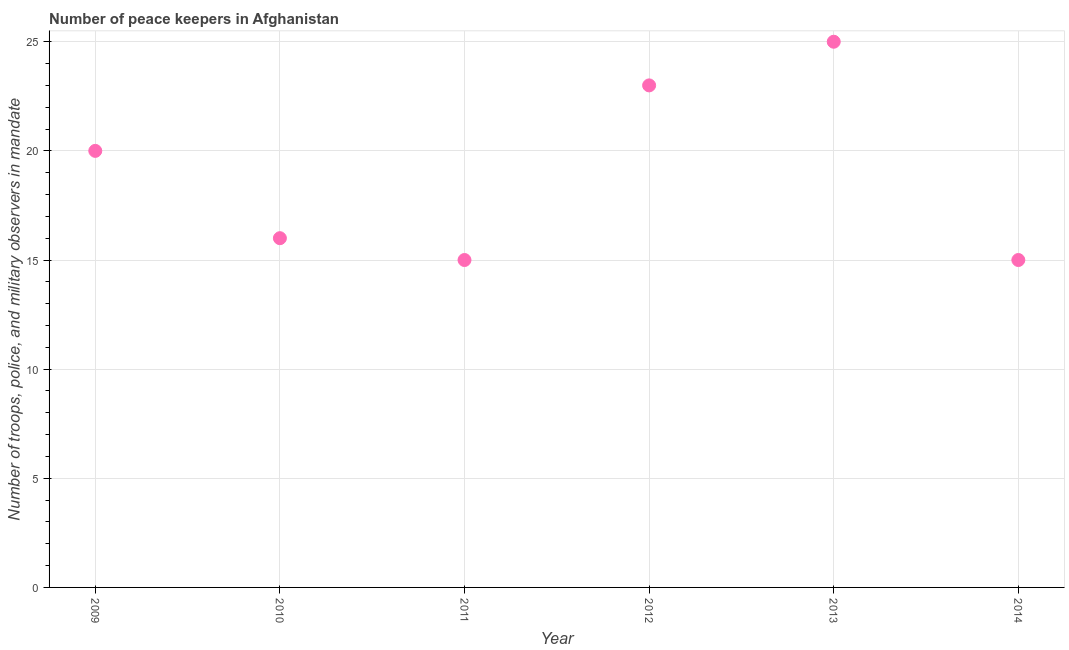What is the number of peace keepers in 2009?
Your response must be concise. 20. Across all years, what is the maximum number of peace keepers?
Ensure brevity in your answer.  25. Across all years, what is the minimum number of peace keepers?
Offer a terse response. 15. In which year was the number of peace keepers maximum?
Offer a terse response. 2013. In which year was the number of peace keepers minimum?
Your answer should be very brief. 2011. What is the sum of the number of peace keepers?
Provide a short and direct response. 114. What is the average number of peace keepers per year?
Keep it short and to the point. 19. In how many years, is the number of peace keepers greater than 23 ?
Ensure brevity in your answer.  1. Do a majority of the years between 2014 and 2013 (inclusive) have number of peace keepers greater than 3 ?
Offer a very short reply. No. What is the ratio of the number of peace keepers in 2012 to that in 2014?
Your answer should be compact. 1.53. Is the difference between the number of peace keepers in 2009 and 2013 greater than the difference between any two years?
Keep it short and to the point. No. What is the difference between the highest and the second highest number of peace keepers?
Your answer should be very brief. 2. What is the difference between the highest and the lowest number of peace keepers?
Make the answer very short. 10. How many dotlines are there?
Offer a terse response. 1. What is the difference between two consecutive major ticks on the Y-axis?
Provide a succinct answer. 5. What is the title of the graph?
Ensure brevity in your answer.  Number of peace keepers in Afghanistan. What is the label or title of the Y-axis?
Offer a very short reply. Number of troops, police, and military observers in mandate. What is the Number of troops, police, and military observers in mandate in 2010?
Keep it short and to the point. 16. What is the Number of troops, police, and military observers in mandate in 2011?
Provide a succinct answer. 15. What is the Number of troops, police, and military observers in mandate in 2012?
Make the answer very short. 23. What is the difference between the Number of troops, police, and military observers in mandate in 2009 and 2010?
Make the answer very short. 4. What is the difference between the Number of troops, police, and military observers in mandate in 2009 and 2013?
Offer a terse response. -5. What is the difference between the Number of troops, police, and military observers in mandate in 2010 and 2012?
Offer a very short reply. -7. What is the difference between the Number of troops, police, and military observers in mandate in 2010 and 2013?
Your answer should be very brief. -9. What is the difference between the Number of troops, police, and military observers in mandate in 2010 and 2014?
Your response must be concise. 1. What is the difference between the Number of troops, police, and military observers in mandate in 2011 and 2013?
Provide a short and direct response. -10. What is the difference between the Number of troops, police, and military observers in mandate in 2012 and 2013?
Keep it short and to the point. -2. What is the ratio of the Number of troops, police, and military observers in mandate in 2009 to that in 2011?
Give a very brief answer. 1.33. What is the ratio of the Number of troops, police, and military observers in mandate in 2009 to that in 2012?
Give a very brief answer. 0.87. What is the ratio of the Number of troops, police, and military observers in mandate in 2009 to that in 2013?
Your response must be concise. 0.8. What is the ratio of the Number of troops, police, and military observers in mandate in 2009 to that in 2014?
Your response must be concise. 1.33. What is the ratio of the Number of troops, police, and military observers in mandate in 2010 to that in 2011?
Offer a terse response. 1.07. What is the ratio of the Number of troops, police, and military observers in mandate in 2010 to that in 2012?
Your answer should be compact. 0.7. What is the ratio of the Number of troops, police, and military observers in mandate in 2010 to that in 2013?
Ensure brevity in your answer.  0.64. What is the ratio of the Number of troops, police, and military observers in mandate in 2010 to that in 2014?
Offer a very short reply. 1.07. What is the ratio of the Number of troops, police, and military observers in mandate in 2011 to that in 2012?
Your response must be concise. 0.65. What is the ratio of the Number of troops, police, and military observers in mandate in 2011 to that in 2013?
Provide a short and direct response. 0.6. What is the ratio of the Number of troops, police, and military observers in mandate in 2011 to that in 2014?
Give a very brief answer. 1. What is the ratio of the Number of troops, police, and military observers in mandate in 2012 to that in 2014?
Your answer should be compact. 1.53. What is the ratio of the Number of troops, police, and military observers in mandate in 2013 to that in 2014?
Keep it short and to the point. 1.67. 